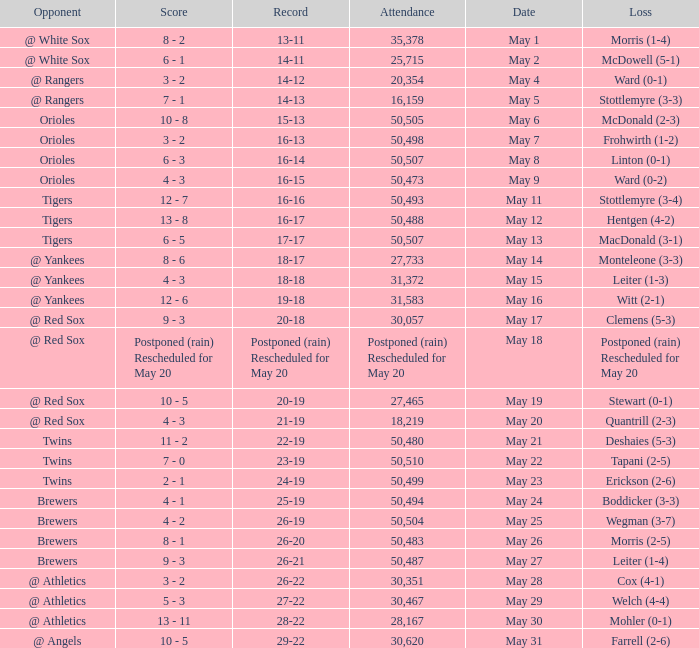Parse the table in full. {'header': ['Opponent', 'Score', 'Record', 'Attendance', 'Date', 'Loss'], 'rows': [['@ White Sox', '8 - 2', '13-11', '35,378', 'May 1', 'Morris (1-4)'], ['@ White Sox', '6 - 1', '14-11', '25,715', 'May 2', 'McDowell (5-1)'], ['@ Rangers', '3 - 2', '14-12', '20,354', 'May 4', 'Ward (0-1)'], ['@ Rangers', '7 - 1', '14-13', '16,159', 'May 5', 'Stottlemyre (3-3)'], ['Orioles', '10 - 8', '15-13', '50,505', 'May 6', 'McDonald (2-3)'], ['Orioles', '3 - 2', '16-13', '50,498', 'May 7', 'Frohwirth (1-2)'], ['Orioles', '6 - 3', '16-14', '50,507', 'May 8', 'Linton (0-1)'], ['Orioles', '4 - 3', '16-15', '50,473', 'May 9', 'Ward (0-2)'], ['Tigers', '12 - 7', '16-16', '50,493', 'May 11', 'Stottlemyre (3-4)'], ['Tigers', '13 - 8', '16-17', '50,488', 'May 12', 'Hentgen (4-2)'], ['Tigers', '6 - 5', '17-17', '50,507', 'May 13', 'MacDonald (3-1)'], ['@ Yankees', '8 - 6', '18-17', '27,733', 'May 14', 'Monteleone (3-3)'], ['@ Yankees', '4 - 3', '18-18', '31,372', 'May 15', 'Leiter (1-3)'], ['@ Yankees', '12 - 6', '19-18', '31,583', 'May 16', 'Witt (2-1)'], ['@ Red Sox', '9 - 3', '20-18', '30,057', 'May 17', 'Clemens (5-3)'], ['@ Red Sox', 'Postponed (rain) Rescheduled for May 20', 'Postponed (rain) Rescheduled for May 20', 'Postponed (rain) Rescheduled for May 20', 'May 18', 'Postponed (rain) Rescheduled for May 20'], ['@ Red Sox', '10 - 5', '20-19', '27,465', 'May 19', 'Stewart (0-1)'], ['@ Red Sox', '4 - 3', '21-19', '18,219', 'May 20', 'Quantrill (2-3)'], ['Twins', '11 - 2', '22-19', '50,480', 'May 21', 'Deshaies (5-3)'], ['Twins', '7 - 0', '23-19', '50,510', 'May 22', 'Tapani (2-5)'], ['Twins', '2 - 1', '24-19', '50,499', 'May 23', 'Erickson (2-6)'], ['Brewers', '4 - 1', '25-19', '50,494', 'May 24', 'Boddicker (3-3)'], ['Brewers', '4 - 2', '26-19', '50,504', 'May 25', 'Wegman (3-7)'], ['Brewers', '8 - 1', '26-20', '50,483', 'May 26', 'Morris (2-5)'], ['Brewers', '9 - 3', '26-21', '50,487', 'May 27', 'Leiter (1-4)'], ['@ Athletics', '3 - 2', '26-22', '30,351', 'May 28', 'Cox (4-1)'], ['@ Athletics', '5 - 3', '27-22', '30,467', 'May 29', 'Welch (4-4)'], ['@ Athletics', '13 - 11', '28-22', '28,167', 'May 30', 'Mohler (0-1)'], ['@ Angels', '10 - 5', '29-22', '30,620', 'May 31', 'Farrell (2-6)']]} On what date was their record 26-19? May 25. 